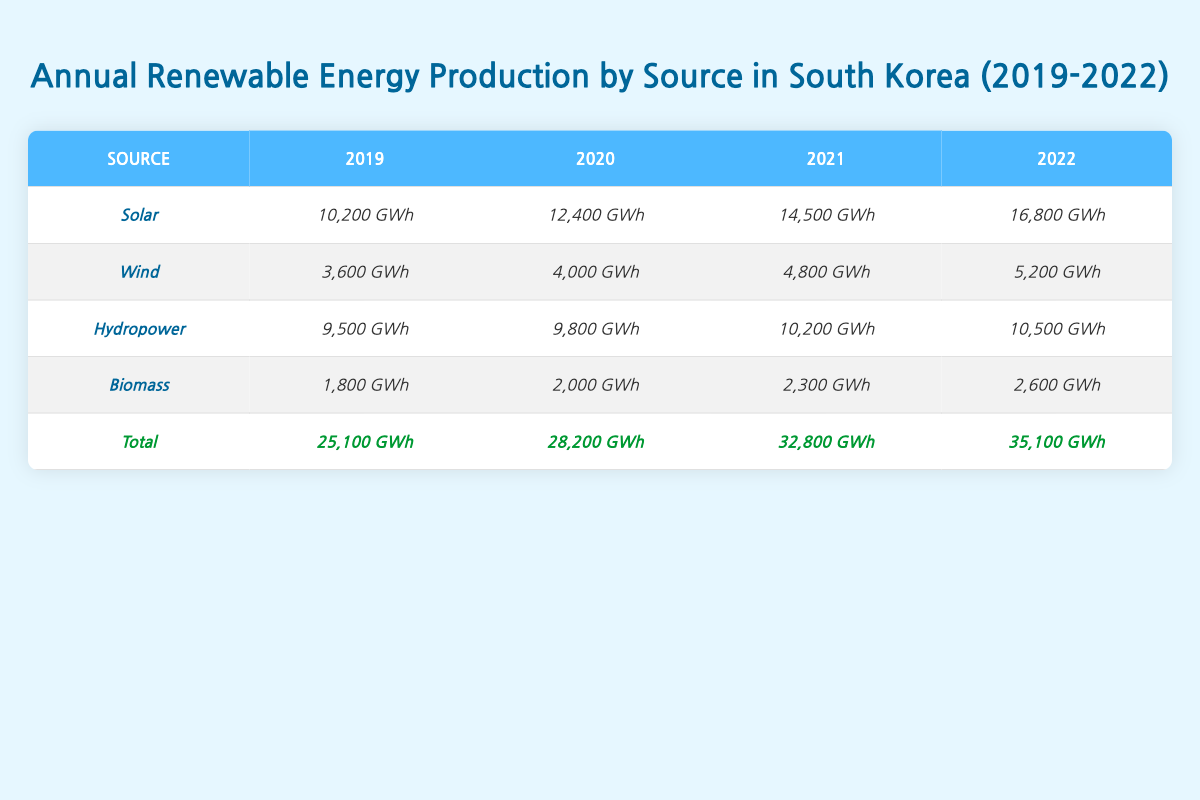What was the total renewable energy production in 2022? In the table, under the Total row for 2022, the value listed is 35,100 GWh.
Answer: 35,100 GWh Which renewable energy source had the highest production in 2021? Looking at the 2021 column for each source, Solar produced 14,500 GWh, which is the highest compared to other sources.
Answer: Solar What is the difference in wind energy production between 2019 and 2022? The wind energy production in 2019 is 3,600 GWh and in 2022 it is 5,200 GWh. Subtracting these gives 5,200 GWh - 3,600 GWh = 1,600 GWh.
Answer: 1,600 GWh What was the average biomass production from 2019 to 2022? Adding biomass production values: (1,800 + 2,000 + 2,300 + 2,600) GWh = 8,700 GWh. There are 4 years, so average = 8,700 GWh / 4 = 2,175 GWh.
Answer: 2,175 GWh Is it true that hydropower production increased every year from 2019 to 2022? Comparing the values for hydropower: 9,500 GWh (2019), 9,800 GWh (2020), 10,200 GWh (2021), and 10,500 GWh (2022) shows an increase each year.
Answer: Yes Which year experienced the greatest increase in total renewable energy production? The total renewable energy production values are: 25,100 GWh (2019), 28,200 GWh (2020), 32,800 GWh (2021), and 35,100 GWh (2022). The greatest increase was from 2021 to 2022, which is 35,100 GWh - 32,800 GWh = 2,300 GWh.
Answer: 2021 to 2022 What percentage of the total renewable energy production in 2022 came from solar energy? In 2022, solar energy production was 16,800 GWh out of a total of 35,100 GWh. The percentage is (16,800 GWh / 35,100 GWh) * 100 = approximately 47.85%.
Answer: 47.85% Compare the total production growth from 2019 to 2022 with the growth of wind energy in the same period. Total production in 2019 was 25,100 GWh and in 2022 it was 35,100 GWh, a growth of 35,100 GWh - 25,100 GWh = 10,000 GWh. For wind energy, it grew from 3,600 GWh (2019) to 5,200 GWh (2022), so growth is 5,200 GWh - 3,600 GWh = 1,600 GWh. The total growth is much larger than wind growth.
Answer: Total: 10,000 GWh, Wind: 1,600 GWh 